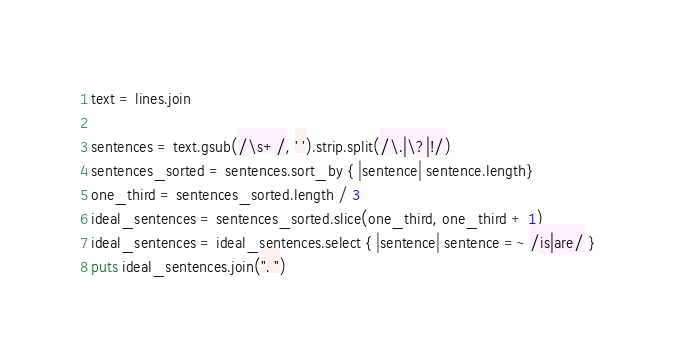<code> <loc_0><loc_0><loc_500><loc_500><_Ruby_>
text = lines.join

sentences = text.gsub(/\s+/, ' ').strip.split(/\.|\?|!/)
sentences_sorted = sentences.sort_by { |sentence| sentence.length}
one_third = sentences_sorted.length / 3
ideal_sentences = sentences_sorted.slice(one_third, one_third + 1)
ideal_sentences = ideal_sentences.select { |sentence| sentence =~ /is|are/ }
puts ideal_sentences.join(". ")</code> 